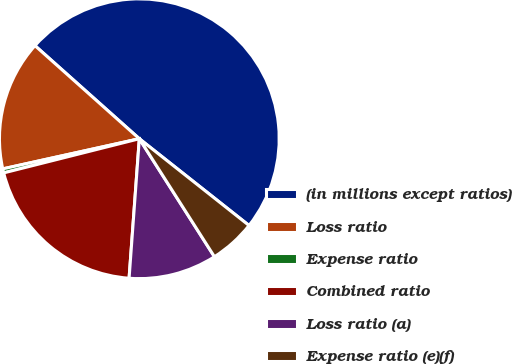Convert chart to OTSL. <chart><loc_0><loc_0><loc_500><loc_500><pie_chart><fcel>(in millions except ratios)<fcel>Loss ratio<fcel>Expense ratio<fcel>Combined ratio<fcel>Loss ratio (a)<fcel>Expense ratio (e)(f)<nl><fcel>49.06%<fcel>15.05%<fcel>0.47%<fcel>19.91%<fcel>10.19%<fcel>5.33%<nl></chart> 